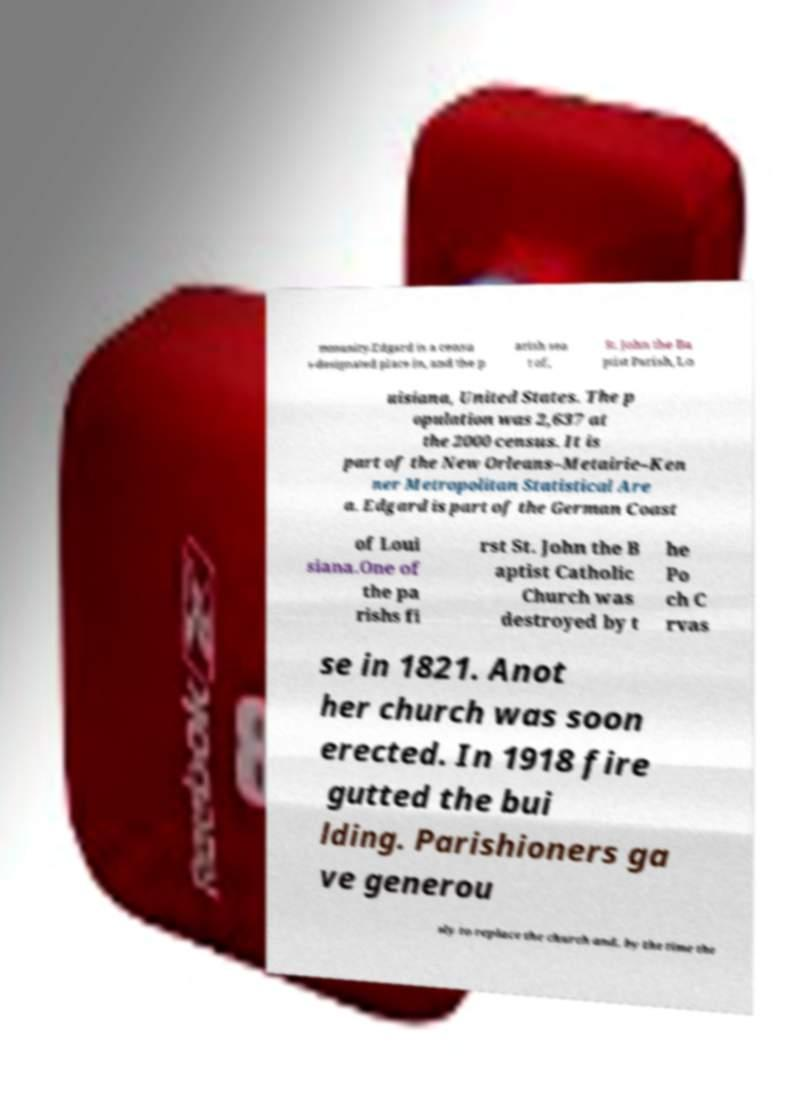Can you read and provide the text displayed in the image?This photo seems to have some interesting text. Can you extract and type it out for me? mmunity.Edgard is a censu s-designated place in, and the p arish sea t of, St. John the Ba ptist Parish, Lo uisiana, United States. The p opulation was 2,637 at the 2000 census. It is part of the New Orleans–Metairie–Ken ner Metropolitan Statistical Are a. Edgard is part of the German Coast of Loui siana.One of the pa rishs fi rst St. John the B aptist Catholic Church was destroyed by t he Po ch C rvas se in 1821. Anot her church was soon erected. In 1918 fire gutted the bui lding. Parishioners ga ve generou sly to replace the church and, by the time the 